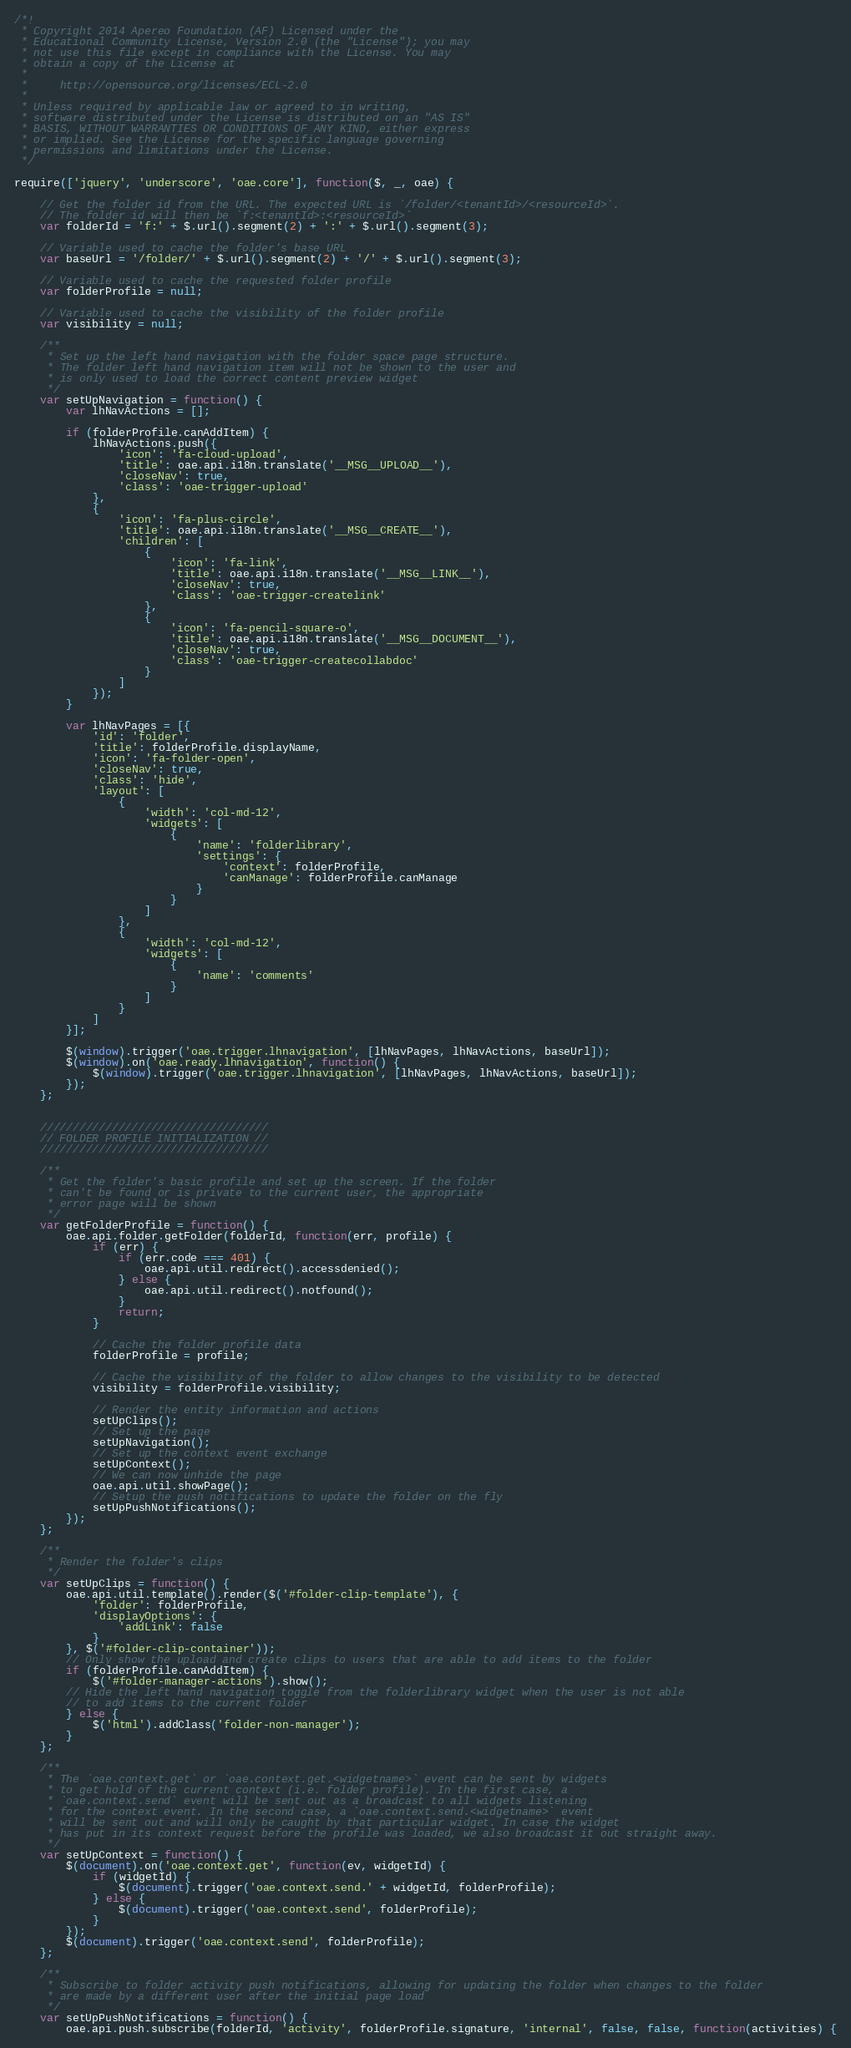Convert code to text. <code><loc_0><loc_0><loc_500><loc_500><_JavaScript_>/*!
 * Copyright 2014 Apereo Foundation (AF) Licensed under the
 * Educational Community License, Version 2.0 (the "License"); you may
 * not use this file except in compliance with the License. You may
 * obtain a copy of the License at
 *
 *     http://opensource.org/licenses/ECL-2.0
 *
 * Unless required by applicable law or agreed to in writing,
 * software distributed under the License is distributed on an "AS IS"
 * BASIS, WITHOUT WARRANTIES OR CONDITIONS OF ANY KIND, either express
 * or implied. See the License for the specific language governing
 * permissions and limitations under the License.
 */

require(['jquery', 'underscore', 'oae.core'], function($, _, oae) {

    // Get the folder id from the URL. The expected URL is `/folder/<tenantId>/<resourceId>`.
    // The folder id will then be `f:<tenantId>:<resourceId>`
    var folderId = 'f:' + $.url().segment(2) + ':' + $.url().segment(3);

    // Variable used to cache the folder's base URL
    var baseUrl = '/folder/' + $.url().segment(2) + '/' + $.url().segment(3);

    // Variable used to cache the requested folder profile
    var folderProfile = null;

    // Variable used to cache the visibility of the folder profile
    var visibility = null;

    /**
     * Set up the left hand navigation with the folder space page structure.
     * The folder left hand navigation item will not be shown to the user and
     * is only used to load the correct content preview widget
     */
    var setUpNavigation = function() {
        var lhNavActions = [];

        if (folderProfile.canAddItem) {
            lhNavActions.push({
                'icon': 'fa-cloud-upload',
                'title': oae.api.i18n.translate('__MSG__UPLOAD__'),
                'closeNav': true,
                'class': 'oae-trigger-upload'
            },
            {
                'icon': 'fa-plus-circle',
                'title': oae.api.i18n.translate('__MSG__CREATE__'),
                'children': [
                    {
                        'icon': 'fa-link',
                        'title': oae.api.i18n.translate('__MSG__LINK__'),
                        'closeNav': true,
                        'class': 'oae-trigger-createlink'
                    },
                    {
                        'icon': 'fa-pencil-square-o',
                        'title': oae.api.i18n.translate('__MSG__DOCUMENT__'),
                        'closeNav': true,
                        'class': 'oae-trigger-createcollabdoc'
                    }
                ]
            });
        }

        var lhNavPages = [{
            'id': 'folder',
            'title': folderProfile.displayName,
            'icon': 'fa-folder-open',
            'closeNav': true,
            'class': 'hide',
            'layout': [
                {
                    'width': 'col-md-12',
                    'widgets': [
                        {
                            'name': 'folderlibrary',
                            'settings': {
                                'context': folderProfile,
                                'canManage': folderProfile.canManage
                            }
                        }
                    ]
                },
                {
                    'width': 'col-md-12',
                    'widgets': [
                        {
                            'name': 'comments'
                        }
                    ]
                }
            ]
        }];

        $(window).trigger('oae.trigger.lhnavigation', [lhNavPages, lhNavActions, baseUrl]);
        $(window).on('oae.ready.lhnavigation', function() {
            $(window).trigger('oae.trigger.lhnavigation', [lhNavPages, lhNavActions, baseUrl]);
        });
    };


    ///////////////////////////////////
    // FOLDER PROFILE INITIALIZATION //
    ///////////////////////////////////

    /**
     * Get the folder's basic profile and set up the screen. If the folder
     * can't be found or is private to the current user, the appropriate
     * error page will be shown
     */
    var getFolderProfile = function() {
        oae.api.folder.getFolder(folderId, function(err, profile) {
            if (err) {
                if (err.code === 401) {
                    oae.api.util.redirect().accessdenied();
                } else {
                    oae.api.util.redirect().notfound();
                }
                return;
            }

            // Cache the folder profile data
            folderProfile = profile;

            // Cache the visibility of the folder to allow changes to the visibility to be detected
            visibility = folderProfile.visibility;

            // Render the entity information and actions
            setUpClips();
            // Set up the page
            setUpNavigation();
            // Set up the context event exchange
            setUpContext();
            // We can now unhide the page
            oae.api.util.showPage();
            // Setup the push notifications to update the folder on the fly
            setUpPushNotifications();
        });
    };

    /**
     * Render the folder's clips
     */
    var setUpClips = function() {
        oae.api.util.template().render($('#folder-clip-template'), {
            'folder': folderProfile,
            'displayOptions': {
                'addLink': false
            }
        }, $('#folder-clip-container'));
        // Only show the upload and create clips to users that are able to add items to the folder
        if (folderProfile.canAddItem) {
            $('#folder-manager-actions').show();
        // Hide the left hand navigation toggle from the folderlibrary widget when the user is not able
        // to add items to the current folder
        } else {
            $('html').addClass('folder-non-manager');
        }
    };

    /**
     * The `oae.context.get` or `oae.context.get.<widgetname>` event can be sent by widgets
     * to get hold of the current context (i.e. folder profile). In the first case, a
     * `oae.context.send` event will be sent out as a broadcast to all widgets listening
     * for the context event. In the second case, a `oae.context.send.<widgetname>` event
     * will be sent out and will only be caught by that particular widget. In case the widget
     * has put in its context request before the profile was loaded, we also broadcast it out straight away.
     */
    var setUpContext = function() {
        $(document).on('oae.context.get', function(ev, widgetId) {
            if (widgetId) {
                $(document).trigger('oae.context.send.' + widgetId, folderProfile);
            } else {
                $(document).trigger('oae.context.send', folderProfile);
            }
        });
        $(document).trigger('oae.context.send', folderProfile);
    };

    /**
     * Subscribe to folder activity push notifications, allowing for updating the folder when changes to the folder
     * are made by a different user after the initial page load
     */
    var setUpPushNotifications = function() {
        oae.api.push.subscribe(folderId, 'activity', folderProfile.signature, 'internal', false, false, function(activities) {</code> 